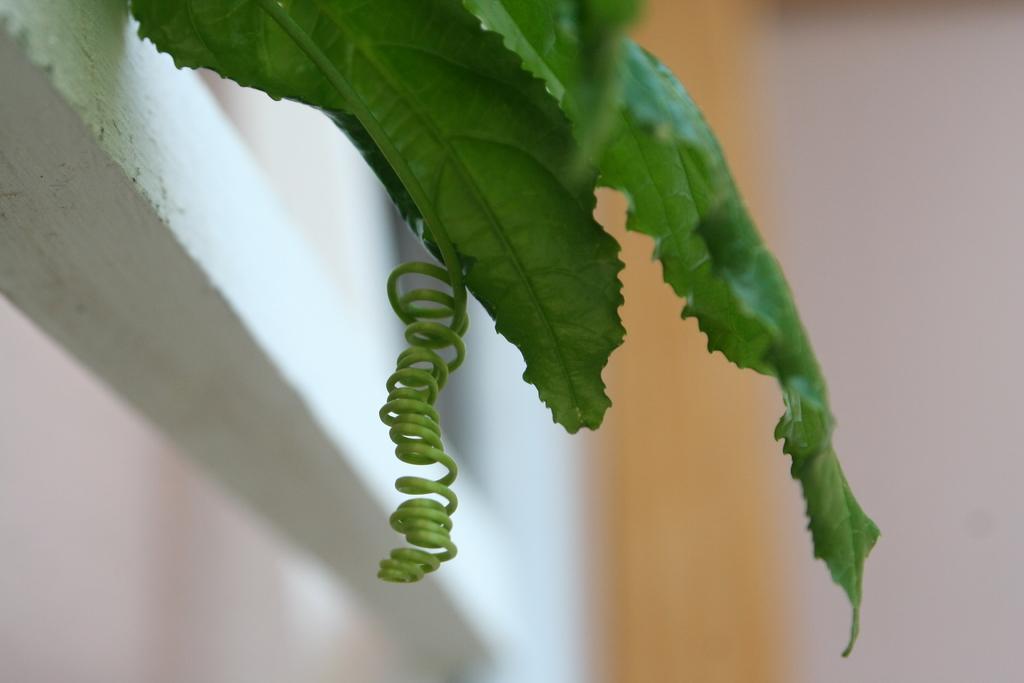In one or two sentences, can you explain what this image depicts? In this picture we can see green leaves and a spiral twig hanging from a white wall. 